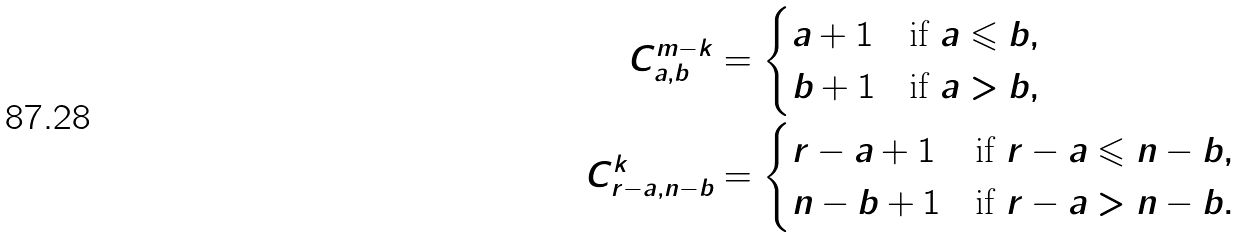<formula> <loc_0><loc_0><loc_500><loc_500>C ^ { m - k } _ { a , b } & = \begin{cases} a + 1 & \text {if $a\leqslant b$} , \\ b + 1 & \text {if $a> b$} , \end{cases} \\ C ^ { k } _ { r - a , n - b } & = \begin{cases} r - a + 1 & \text {if $r-a\leqslant n-b$} , \\ n - b + 1 & \text {if $r-a>n-b$} . \end{cases}</formula> 